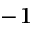Convert formula to latex. <formula><loc_0><loc_0><loc_500><loc_500>^ { - 1 }</formula> 